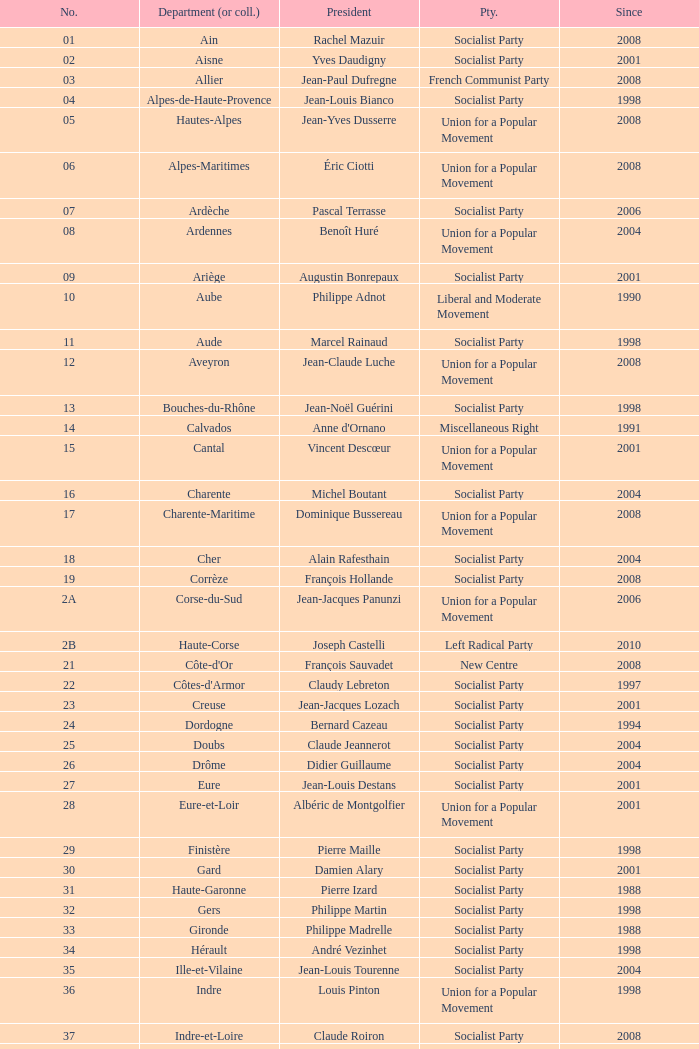Who is the president representing the Creuse department? Jean-Jacques Lozach. 